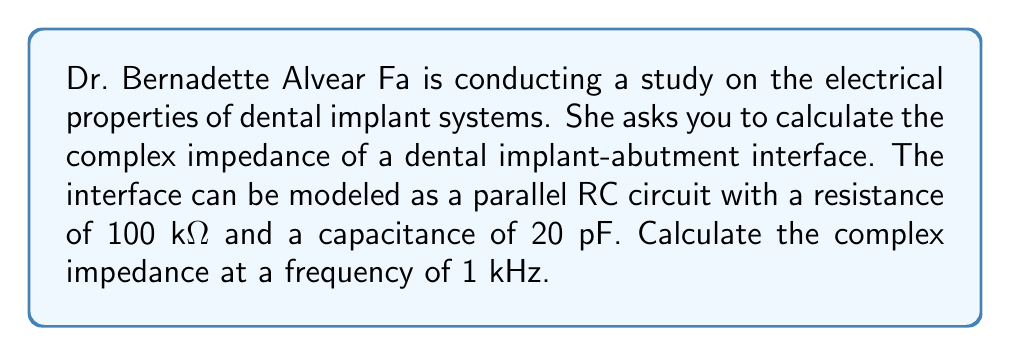What is the answer to this math problem? To solve this problem, we'll follow these steps:

1) In a parallel RC circuit, the complex impedance is given by:

   $$Z = \frac{1}{\frac{1}{R} + j\omega C}$$

   where $R$ is resistance, $C$ is capacitance, $\omega$ is angular frequency, and $j$ is the imaginary unit.

2) We're given:
   $R = 100 \text{ k}\Omega = 100,000 \Omega$
   $C = 20 \text{ pF} = 20 \times 10^{-12} \text{ F}$
   $f = 1 \text{ kHz} = 1000 \text{ Hz}$

3) First, calculate $\omega$:
   $$\omega = 2\pi f = 2\pi(1000) = 6283.19 \text{ rad/s}$$

4) Now, substitute these values into the impedance formula:

   $$Z = \frac{1}{\frac{1}{100,000} + j(6283.19)(20 \times 10^{-12})}$$

5) Simplify:
   $$Z = \frac{1}{1 \times 10^{-5} + j(1.26638 \times 10^{-7})}$$

6) To rationalize the denominator, multiply numerator and denominator by the complex conjugate of the denominator:

   $$Z = \frac{1 \times 10^{-5} - j(1.26638 \times 10^{-7})}{(1 \times 10^{-5})^2 + (1.26638 \times 10^{-7})^2}$$

7) Simplify:
   $$Z = \frac{1 \times 10^{-5} - j(1.26638 \times 10^{-7})}{1.00016 \times 10^{-10}}$$

8) Separate real and imaginary parts:
   $$Z = (99,984 - j1266.36) \Omega$$

This is the complex impedance of the dental implant-abutment interface.
Answer: $Z = (99,984 - j1266.36) \Omega$ 